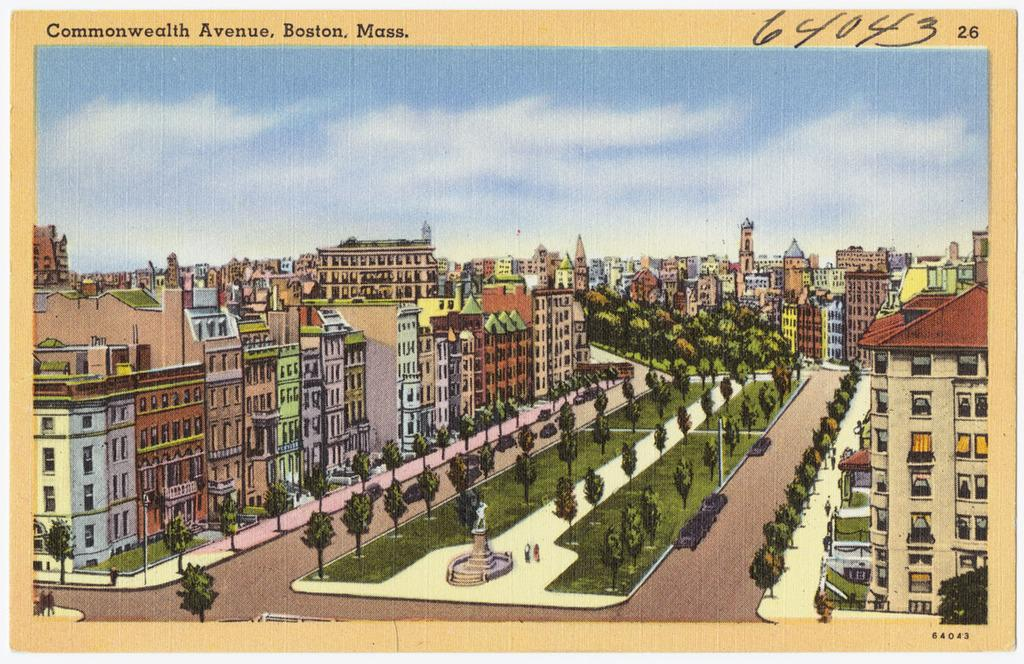What is the main subject of the poster in the image? The poster contains images of buildings, trees, grass, people, and the sky with clouds. What type of images can be seen on the poster? The poster contains images of buildings, trees, grass, people, and the sky with clouds. Are there any text or numbers on the poster? Yes, there is text and numbers at the top of the poster. What type of stew is being served in the image? There is no stew present in the image; it features a poster with various images and text. What color is the skirt worn by the person in the image? There is no person wearing a skirt in the image; it features a poster with various images and text. 